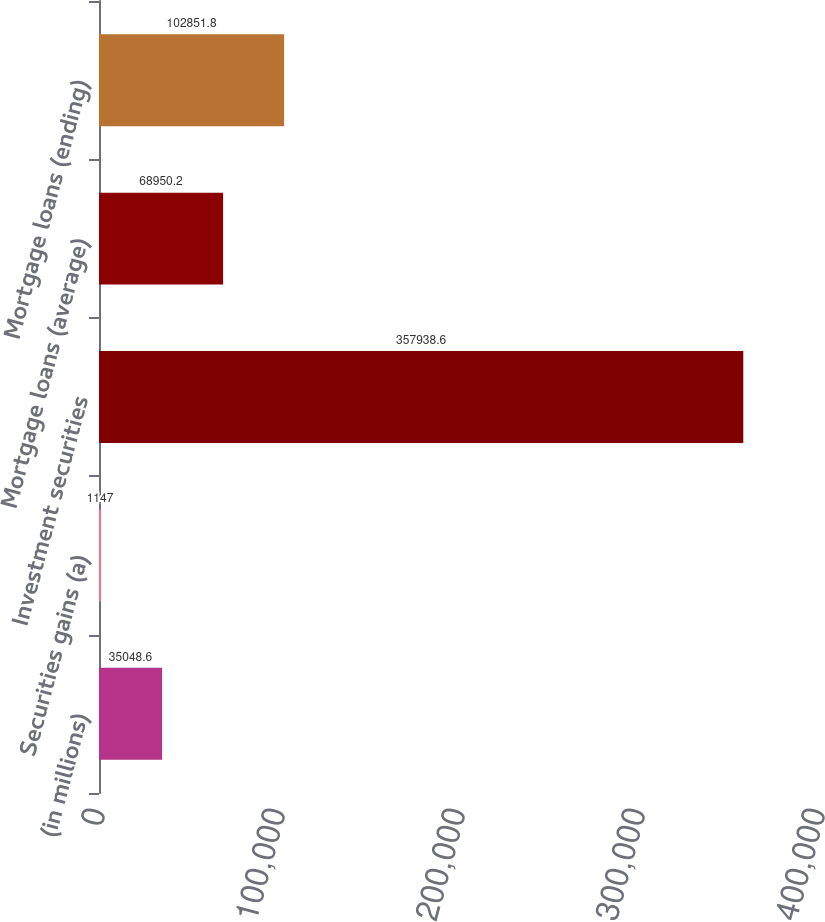<chart> <loc_0><loc_0><loc_500><loc_500><bar_chart><fcel>(in millions)<fcel>Securities gains (a)<fcel>Investment securities<fcel>Mortgage loans (average)<fcel>Mortgage loans (ending)<nl><fcel>35048.6<fcel>1147<fcel>357939<fcel>68950.2<fcel>102852<nl></chart> 